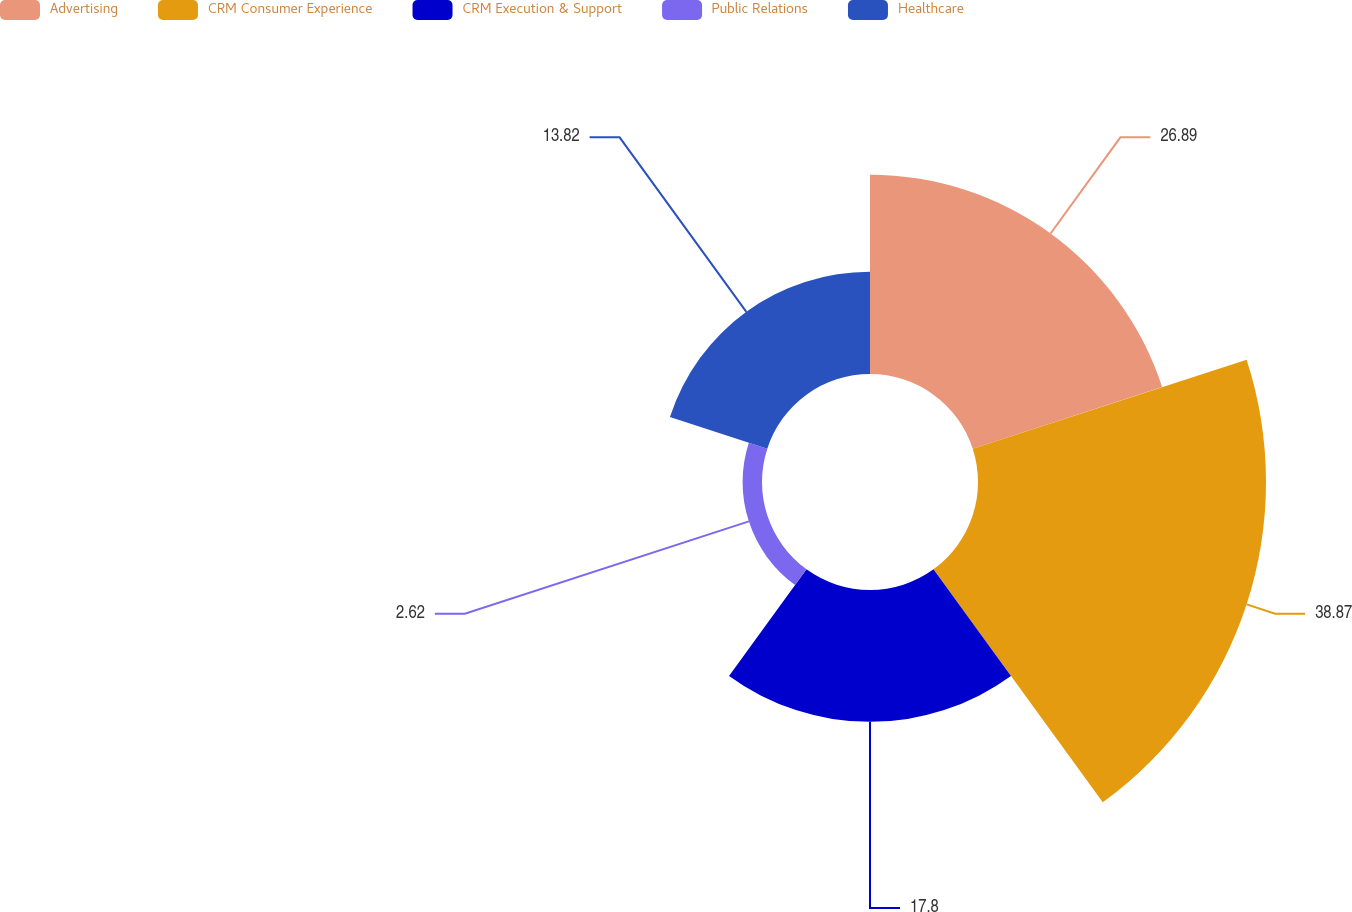<chart> <loc_0><loc_0><loc_500><loc_500><pie_chart><fcel>Advertising<fcel>CRM Consumer Experience<fcel>CRM Execution & Support<fcel>Public Relations<fcel>Healthcare<nl><fcel>26.89%<fcel>38.88%<fcel>17.8%<fcel>2.62%<fcel>13.82%<nl></chart> 